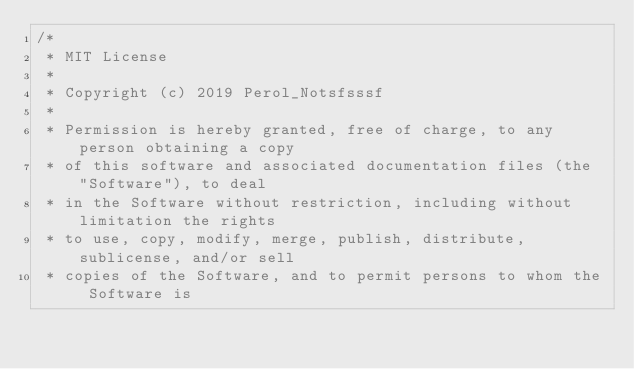Convert code to text. <code><loc_0><loc_0><loc_500><loc_500><_Kotlin_>/*
 * MIT License
 *
 * Copyright (c) 2019 Perol_Notsfsssf
 *
 * Permission is hereby granted, free of charge, to any person obtaining a copy
 * of this software and associated documentation files (the "Software"), to deal
 * in the Software without restriction, including without limitation the rights
 * to use, copy, modify, merge, publish, distribute, sublicense, and/or sell
 * copies of the Software, and to permit persons to whom the Software is</code> 